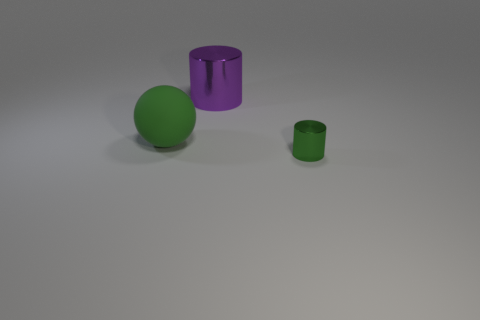How many big cylinders are the same color as the big matte sphere?
Offer a very short reply. 0. The cylinder behind the green thing to the right of the purple object is made of what material?
Provide a short and direct response. Metal. The green shiny cylinder has what size?
Offer a very short reply. Small. What number of green shiny cylinders are the same size as the purple metallic thing?
Ensure brevity in your answer.  0. How many other tiny metallic things are the same shape as the green shiny thing?
Provide a short and direct response. 0. Are there an equal number of small things that are in front of the big purple metallic cylinder and small brown rubber cylinders?
Your answer should be very brief. No. Are there any other things that have the same size as the purple cylinder?
Keep it short and to the point. Yes. There is a green rubber object that is the same size as the purple thing; what is its shape?
Provide a succinct answer. Sphere. Is there another large green object of the same shape as the green metallic object?
Give a very brief answer. No. There is a shiny cylinder that is behind the metal object to the right of the big purple cylinder; are there any big cylinders that are in front of it?
Your response must be concise. No. 